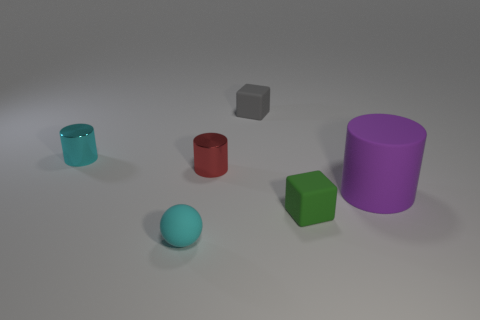Add 4 small red objects. How many objects exist? 10 Subtract all balls. How many objects are left? 5 Add 2 tiny gray rubber cubes. How many tiny gray rubber cubes are left? 3 Add 2 gray objects. How many gray objects exist? 3 Subtract 0 yellow cubes. How many objects are left? 6 Subtract all tiny green matte things. Subtract all big purple matte objects. How many objects are left? 4 